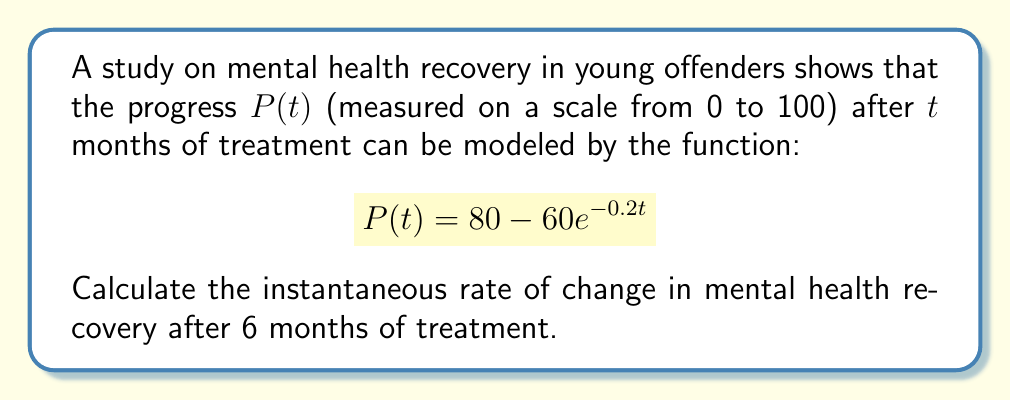Give your solution to this math problem. To find the instantaneous rate of change, we need to calculate the derivative of $P(t)$ and evaluate it at $t=6$.

Step 1: Calculate the derivative of $P(t)$
$$\frac{d}{dt}P(t) = \frac{d}{dt}(80 - 60e^{-0.2t})$$
$$P'(t) = 0 - 60 \cdot (-0.2e^{-0.2t})$$
$$P'(t) = 12e^{-0.2t}$$

Step 2: Evaluate $P'(t)$ at $t=6$
$$P'(6) = 12e^{-0.2(6)}$$
$$P'(6) = 12e^{-1.2}$$
$$P'(6) \approx 3.62$$

The instantaneous rate of change after 6 months is approximately 3.62 units per month.
Answer: $3.62$ units/month 